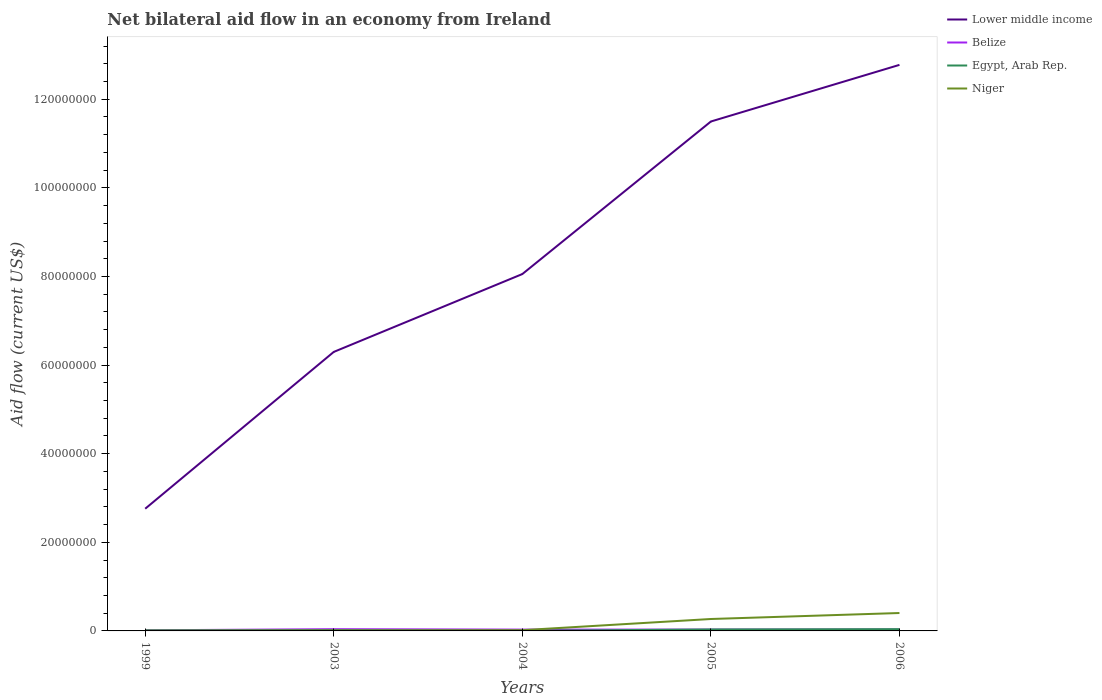How many different coloured lines are there?
Give a very brief answer. 4. Is the number of lines equal to the number of legend labels?
Your response must be concise. Yes. Across all years, what is the maximum net bilateral aid flow in Lower middle income?
Give a very brief answer. 2.76e+07. In which year was the net bilateral aid flow in Lower middle income maximum?
Give a very brief answer. 1999. What is the total net bilateral aid flow in Niger in the graph?
Offer a very short reply. -1.30e+05. What is the difference between the highest and the second highest net bilateral aid flow in Lower middle income?
Your response must be concise. 1.00e+08. What is the difference between the highest and the lowest net bilateral aid flow in Egypt, Arab Rep.?
Your answer should be very brief. 2. Is the net bilateral aid flow in Niger strictly greater than the net bilateral aid flow in Lower middle income over the years?
Provide a succinct answer. Yes. How many years are there in the graph?
Give a very brief answer. 5. Are the values on the major ticks of Y-axis written in scientific E-notation?
Ensure brevity in your answer.  No. Does the graph contain grids?
Offer a terse response. No. Where does the legend appear in the graph?
Ensure brevity in your answer.  Top right. How many legend labels are there?
Ensure brevity in your answer.  4. How are the legend labels stacked?
Provide a succinct answer. Vertical. What is the title of the graph?
Your response must be concise. Net bilateral aid flow in an economy from Ireland. Does "Senegal" appear as one of the legend labels in the graph?
Your response must be concise. No. What is the label or title of the X-axis?
Ensure brevity in your answer.  Years. What is the label or title of the Y-axis?
Your answer should be very brief. Aid flow (current US$). What is the Aid flow (current US$) of Lower middle income in 1999?
Provide a short and direct response. 2.76e+07. What is the Aid flow (current US$) of Belize in 1999?
Offer a terse response. 1.40e+05. What is the Aid flow (current US$) in Egypt, Arab Rep. in 1999?
Your response must be concise. 1.20e+05. What is the Aid flow (current US$) of Niger in 1999?
Ensure brevity in your answer.  4.00e+04. What is the Aid flow (current US$) of Lower middle income in 2003?
Ensure brevity in your answer.  6.30e+07. What is the Aid flow (current US$) of Belize in 2003?
Your answer should be very brief. 3.90e+05. What is the Aid flow (current US$) in Egypt, Arab Rep. in 2003?
Keep it short and to the point. 1.50e+05. What is the Aid flow (current US$) in Niger in 2003?
Offer a very short reply. 1.10e+05. What is the Aid flow (current US$) of Lower middle income in 2004?
Your answer should be compact. 8.05e+07. What is the Aid flow (current US$) in Egypt, Arab Rep. in 2004?
Ensure brevity in your answer.  2.00e+04. What is the Aid flow (current US$) in Niger in 2004?
Give a very brief answer. 1.70e+05. What is the Aid flow (current US$) in Lower middle income in 2005?
Make the answer very short. 1.15e+08. What is the Aid flow (current US$) in Egypt, Arab Rep. in 2005?
Your answer should be very brief. 3.30e+05. What is the Aid flow (current US$) in Niger in 2005?
Give a very brief answer. 2.69e+06. What is the Aid flow (current US$) in Lower middle income in 2006?
Offer a very short reply. 1.28e+08. What is the Aid flow (current US$) in Belize in 2006?
Offer a terse response. 3.10e+05. What is the Aid flow (current US$) of Egypt, Arab Rep. in 2006?
Your response must be concise. 4.00e+05. What is the Aid flow (current US$) in Niger in 2006?
Keep it short and to the point. 4.04e+06. Across all years, what is the maximum Aid flow (current US$) in Lower middle income?
Your response must be concise. 1.28e+08. Across all years, what is the maximum Aid flow (current US$) of Niger?
Your answer should be compact. 4.04e+06. Across all years, what is the minimum Aid flow (current US$) of Lower middle income?
Your answer should be compact. 2.76e+07. Across all years, what is the minimum Aid flow (current US$) in Niger?
Offer a very short reply. 4.00e+04. What is the total Aid flow (current US$) in Lower middle income in the graph?
Keep it short and to the point. 4.14e+08. What is the total Aid flow (current US$) of Belize in the graph?
Offer a very short reply. 1.44e+06. What is the total Aid flow (current US$) in Egypt, Arab Rep. in the graph?
Provide a short and direct response. 1.02e+06. What is the total Aid flow (current US$) in Niger in the graph?
Offer a terse response. 7.05e+06. What is the difference between the Aid flow (current US$) of Lower middle income in 1999 and that in 2003?
Provide a short and direct response. -3.54e+07. What is the difference between the Aid flow (current US$) in Belize in 1999 and that in 2003?
Your response must be concise. -2.50e+05. What is the difference between the Aid flow (current US$) in Egypt, Arab Rep. in 1999 and that in 2003?
Give a very brief answer. -3.00e+04. What is the difference between the Aid flow (current US$) in Lower middle income in 1999 and that in 2004?
Give a very brief answer. -5.30e+07. What is the difference between the Aid flow (current US$) in Belize in 1999 and that in 2004?
Provide a short and direct response. -1.60e+05. What is the difference between the Aid flow (current US$) of Egypt, Arab Rep. in 1999 and that in 2004?
Make the answer very short. 1.00e+05. What is the difference between the Aid flow (current US$) of Niger in 1999 and that in 2004?
Your answer should be compact. -1.30e+05. What is the difference between the Aid flow (current US$) in Lower middle income in 1999 and that in 2005?
Ensure brevity in your answer.  -8.74e+07. What is the difference between the Aid flow (current US$) of Egypt, Arab Rep. in 1999 and that in 2005?
Your response must be concise. -2.10e+05. What is the difference between the Aid flow (current US$) of Niger in 1999 and that in 2005?
Keep it short and to the point. -2.65e+06. What is the difference between the Aid flow (current US$) of Lower middle income in 1999 and that in 2006?
Your answer should be very brief. -1.00e+08. What is the difference between the Aid flow (current US$) of Egypt, Arab Rep. in 1999 and that in 2006?
Make the answer very short. -2.80e+05. What is the difference between the Aid flow (current US$) of Niger in 1999 and that in 2006?
Keep it short and to the point. -4.00e+06. What is the difference between the Aid flow (current US$) in Lower middle income in 2003 and that in 2004?
Give a very brief answer. -1.76e+07. What is the difference between the Aid flow (current US$) in Lower middle income in 2003 and that in 2005?
Ensure brevity in your answer.  -5.20e+07. What is the difference between the Aid flow (current US$) in Egypt, Arab Rep. in 2003 and that in 2005?
Ensure brevity in your answer.  -1.80e+05. What is the difference between the Aid flow (current US$) in Niger in 2003 and that in 2005?
Provide a succinct answer. -2.58e+06. What is the difference between the Aid flow (current US$) of Lower middle income in 2003 and that in 2006?
Keep it short and to the point. -6.48e+07. What is the difference between the Aid flow (current US$) in Niger in 2003 and that in 2006?
Make the answer very short. -3.93e+06. What is the difference between the Aid flow (current US$) in Lower middle income in 2004 and that in 2005?
Provide a short and direct response. -3.44e+07. What is the difference between the Aid flow (current US$) in Belize in 2004 and that in 2005?
Your answer should be very brief. 0. What is the difference between the Aid flow (current US$) of Egypt, Arab Rep. in 2004 and that in 2005?
Offer a very short reply. -3.10e+05. What is the difference between the Aid flow (current US$) in Niger in 2004 and that in 2005?
Provide a short and direct response. -2.52e+06. What is the difference between the Aid flow (current US$) of Lower middle income in 2004 and that in 2006?
Your response must be concise. -4.72e+07. What is the difference between the Aid flow (current US$) in Egypt, Arab Rep. in 2004 and that in 2006?
Keep it short and to the point. -3.80e+05. What is the difference between the Aid flow (current US$) in Niger in 2004 and that in 2006?
Ensure brevity in your answer.  -3.87e+06. What is the difference between the Aid flow (current US$) in Lower middle income in 2005 and that in 2006?
Make the answer very short. -1.28e+07. What is the difference between the Aid flow (current US$) in Niger in 2005 and that in 2006?
Give a very brief answer. -1.35e+06. What is the difference between the Aid flow (current US$) of Lower middle income in 1999 and the Aid flow (current US$) of Belize in 2003?
Give a very brief answer. 2.72e+07. What is the difference between the Aid flow (current US$) in Lower middle income in 1999 and the Aid flow (current US$) in Egypt, Arab Rep. in 2003?
Provide a succinct answer. 2.74e+07. What is the difference between the Aid flow (current US$) in Lower middle income in 1999 and the Aid flow (current US$) in Niger in 2003?
Offer a very short reply. 2.75e+07. What is the difference between the Aid flow (current US$) in Belize in 1999 and the Aid flow (current US$) in Niger in 2003?
Provide a succinct answer. 3.00e+04. What is the difference between the Aid flow (current US$) of Egypt, Arab Rep. in 1999 and the Aid flow (current US$) of Niger in 2003?
Your answer should be compact. 10000. What is the difference between the Aid flow (current US$) of Lower middle income in 1999 and the Aid flow (current US$) of Belize in 2004?
Your response must be concise. 2.73e+07. What is the difference between the Aid flow (current US$) of Lower middle income in 1999 and the Aid flow (current US$) of Egypt, Arab Rep. in 2004?
Offer a terse response. 2.76e+07. What is the difference between the Aid flow (current US$) in Lower middle income in 1999 and the Aid flow (current US$) in Niger in 2004?
Provide a succinct answer. 2.74e+07. What is the difference between the Aid flow (current US$) in Belize in 1999 and the Aid flow (current US$) in Egypt, Arab Rep. in 2004?
Keep it short and to the point. 1.20e+05. What is the difference between the Aid flow (current US$) of Egypt, Arab Rep. in 1999 and the Aid flow (current US$) of Niger in 2004?
Provide a succinct answer. -5.00e+04. What is the difference between the Aid flow (current US$) in Lower middle income in 1999 and the Aid flow (current US$) in Belize in 2005?
Make the answer very short. 2.73e+07. What is the difference between the Aid flow (current US$) in Lower middle income in 1999 and the Aid flow (current US$) in Egypt, Arab Rep. in 2005?
Give a very brief answer. 2.72e+07. What is the difference between the Aid flow (current US$) of Lower middle income in 1999 and the Aid flow (current US$) of Niger in 2005?
Provide a short and direct response. 2.49e+07. What is the difference between the Aid flow (current US$) of Belize in 1999 and the Aid flow (current US$) of Egypt, Arab Rep. in 2005?
Provide a short and direct response. -1.90e+05. What is the difference between the Aid flow (current US$) of Belize in 1999 and the Aid flow (current US$) of Niger in 2005?
Make the answer very short. -2.55e+06. What is the difference between the Aid flow (current US$) of Egypt, Arab Rep. in 1999 and the Aid flow (current US$) of Niger in 2005?
Your response must be concise. -2.57e+06. What is the difference between the Aid flow (current US$) in Lower middle income in 1999 and the Aid flow (current US$) in Belize in 2006?
Offer a terse response. 2.73e+07. What is the difference between the Aid flow (current US$) of Lower middle income in 1999 and the Aid flow (current US$) of Egypt, Arab Rep. in 2006?
Your response must be concise. 2.72e+07. What is the difference between the Aid flow (current US$) in Lower middle income in 1999 and the Aid flow (current US$) in Niger in 2006?
Your answer should be compact. 2.35e+07. What is the difference between the Aid flow (current US$) of Belize in 1999 and the Aid flow (current US$) of Niger in 2006?
Give a very brief answer. -3.90e+06. What is the difference between the Aid flow (current US$) of Egypt, Arab Rep. in 1999 and the Aid flow (current US$) of Niger in 2006?
Give a very brief answer. -3.92e+06. What is the difference between the Aid flow (current US$) in Lower middle income in 2003 and the Aid flow (current US$) in Belize in 2004?
Provide a short and direct response. 6.27e+07. What is the difference between the Aid flow (current US$) in Lower middle income in 2003 and the Aid flow (current US$) in Egypt, Arab Rep. in 2004?
Provide a succinct answer. 6.30e+07. What is the difference between the Aid flow (current US$) of Lower middle income in 2003 and the Aid flow (current US$) of Niger in 2004?
Provide a succinct answer. 6.28e+07. What is the difference between the Aid flow (current US$) of Belize in 2003 and the Aid flow (current US$) of Egypt, Arab Rep. in 2004?
Your answer should be compact. 3.70e+05. What is the difference between the Aid flow (current US$) of Lower middle income in 2003 and the Aid flow (current US$) of Belize in 2005?
Make the answer very short. 6.27e+07. What is the difference between the Aid flow (current US$) of Lower middle income in 2003 and the Aid flow (current US$) of Egypt, Arab Rep. in 2005?
Offer a very short reply. 6.26e+07. What is the difference between the Aid flow (current US$) in Lower middle income in 2003 and the Aid flow (current US$) in Niger in 2005?
Provide a succinct answer. 6.03e+07. What is the difference between the Aid flow (current US$) of Belize in 2003 and the Aid flow (current US$) of Egypt, Arab Rep. in 2005?
Your answer should be compact. 6.00e+04. What is the difference between the Aid flow (current US$) in Belize in 2003 and the Aid flow (current US$) in Niger in 2005?
Offer a very short reply. -2.30e+06. What is the difference between the Aid flow (current US$) in Egypt, Arab Rep. in 2003 and the Aid flow (current US$) in Niger in 2005?
Give a very brief answer. -2.54e+06. What is the difference between the Aid flow (current US$) in Lower middle income in 2003 and the Aid flow (current US$) in Belize in 2006?
Offer a very short reply. 6.27e+07. What is the difference between the Aid flow (current US$) of Lower middle income in 2003 and the Aid flow (current US$) of Egypt, Arab Rep. in 2006?
Provide a short and direct response. 6.26e+07. What is the difference between the Aid flow (current US$) of Lower middle income in 2003 and the Aid flow (current US$) of Niger in 2006?
Your answer should be compact. 5.89e+07. What is the difference between the Aid flow (current US$) of Belize in 2003 and the Aid flow (current US$) of Niger in 2006?
Provide a short and direct response. -3.65e+06. What is the difference between the Aid flow (current US$) in Egypt, Arab Rep. in 2003 and the Aid flow (current US$) in Niger in 2006?
Your response must be concise. -3.89e+06. What is the difference between the Aid flow (current US$) of Lower middle income in 2004 and the Aid flow (current US$) of Belize in 2005?
Make the answer very short. 8.02e+07. What is the difference between the Aid flow (current US$) of Lower middle income in 2004 and the Aid flow (current US$) of Egypt, Arab Rep. in 2005?
Ensure brevity in your answer.  8.02e+07. What is the difference between the Aid flow (current US$) in Lower middle income in 2004 and the Aid flow (current US$) in Niger in 2005?
Give a very brief answer. 7.78e+07. What is the difference between the Aid flow (current US$) of Belize in 2004 and the Aid flow (current US$) of Egypt, Arab Rep. in 2005?
Your response must be concise. -3.00e+04. What is the difference between the Aid flow (current US$) in Belize in 2004 and the Aid flow (current US$) in Niger in 2005?
Offer a terse response. -2.39e+06. What is the difference between the Aid flow (current US$) in Egypt, Arab Rep. in 2004 and the Aid flow (current US$) in Niger in 2005?
Your answer should be very brief. -2.67e+06. What is the difference between the Aid flow (current US$) of Lower middle income in 2004 and the Aid flow (current US$) of Belize in 2006?
Offer a terse response. 8.02e+07. What is the difference between the Aid flow (current US$) of Lower middle income in 2004 and the Aid flow (current US$) of Egypt, Arab Rep. in 2006?
Keep it short and to the point. 8.01e+07. What is the difference between the Aid flow (current US$) in Lower middle income in 2004 and the Aid flow (current US$) in Niger in 2006?
Your answer should be compact. 7.65e+07. What is the difference between the Aid flow (current US$) in Belize in 2004 and the Aid flow (current US$) in Egypt, Arab Rep. in 2006?
Provide a succinct answer. -1.00e+05. What is the difference between the Aid flow (current US$) of Belize in 2004 and the Aid flow (current US$) of Niger in 2006?
Your answer should be compact. -3.74e+06. What is the difference between the Aid flow (current US$) in Egypt, Arab Rep. in 2004 and the Aid flow (current US$) in Niger in 2006?
Keep it short and to the point. -4.02e+06. What is the difference between the Aid flow (current US$) of Lower middle income in 2005 and the Aid flow (current US$) of Belize in 2006?
Provide a succinct answer. 1.15e+08. What is the difference between the Aid flow (current US$) of Lower middle income in 2005 and the Aid flow (current US$) of Egypt, Arab Rep. in 2006?
Your answer should be compact. 1.15e+08. What is the difference between the Aid flow (current US$) in Lower middle income in 2005 and the Aid flow (current US$) in Niger in 2006?
Your answer should be very brief. 1.11e+08. What is the difference between the Aid flow (current US$) of Belize in 2005 and the Aid flow (current US$) of Niger in 2006?
Your response must be concise. -3.74e+06. What is the difference between the Aid flow (current US$) of Egypt, Arab Rep. in 2005 and the Aid flow (current US$) of Niger in 2006?
Keep it short and to the point. -3.71e+06. What is the average Aid flow (current US$) of Lower middle income per year?
Keep it short and to the point. 8.28e+07. What is the average Aid flow (current US$) of Belize per year?
Your answer should be very brief. 2.88e+05. What is the average Aid flow (current US$) of Egypt, Arab Rep. per year?
Ensure brevity in your answer.  2.04e+05. What is the average Aid flow (current US$) of Niger per year?
Make the answer very short. 1.41e+06. In the year 1999, what is the difference between the Aid flow (current US$) in Lower middle income and Aid flow (current US$) in Belize?
Your answer should be compact. 2.74e+07. In the year 1999, what is the difference between the Aid flow (current US$) in Lower middle income and Aid flow (current US$) in Egypt, Arab Rep.?
Your answer should be very brief. 2.75e+07. In the year 1999, what is the difference between the Aid flow (current US$) of Lower middle income and Aid flow (current US$) of Niger?
Provide a succinct answer. 2.75e+07. In the year 1999, what is the difference between the Aid flow (current US$) of Belize and Aid flow (current US$) of Niger?
Provide a short and direct response. 1.00e+05. In the year 1999, what is the difference between the Aid flow (current US$) in Egypt, Arab Rep. and Aid flow (current US$) in Niger?
Offer a very short reply. 8.00e+04. In the year 2003, what is the difference between the Aid flow (current US$) in Lower middle income and Aid flow (current US$) in Belize?
Your answer should be very brief. 6.26e+07. In the year 2003, what is the difference between the Aid flow (current US$) in Lower middle income and Aid flow (current US$) in Egypt, Arab Rep.?
Offer a very short reply. 6.28e+07. In the year 2003, what is the difference between the Aid flow (current US$) of Lower middle income and Aid flow (current US$) of Niger?
Make the answer very short. 6.29e+07. In the year 2003, what is the difference between the Aid flow (current US$) in Belize and Aid flow (current US$) in Niger?
Offer a terse response. 2.80e+05. In the year 2004, what is the difference between the Aid flow (current US$) of Lower middle income and Aid flow (current US$) of Belize?
Your answer should be compact. 8.02e+07. In the year 2004, what is the difference between the Aid flow (current US$) in Lower middle income and Aid flow (current US$) in Egypt, Arab Rep.?
Your response must be concise. 8.05e+07. In the year 2004, what is the difference between the Aid flow (current US$) of Lower middle income and Aid flow (current US$) of Niger?
Ensure brevity in your answer.  8.04e+07. In the year 2004, what is the difference between the Aid flow (current US$) in Belize and Aid flow (current US$) in Niger?
Your answer should be very brief. 1.30e+05. In the year 2004, what is the difference between the Aid flow (current US$) in Egypt, Arab Rep. and Aid flow (current US$) in Niger?
Your answer should be very brief. -1.50e+05. In the year 2005, what is the difference between the Aid flow (current US$) in Lower middle income and Aid flow (current US$) in Belize?
Make the answer very short. 1.15e+08. In the year 2005, what is the difference between the Aid flow (current US$) of Lower middle income and Aid flow (current US$) of Egypt, Arab Rep.?
Ensure brevity in your answer.  1.15e+08. In the year 2005, what is the difference between the Aid flow (current US$) of Lower middle income and Aid flow (current US$) of Niger?
Your answer should be compact. 1.12e+08. In the year 2005, what is the difference between the Aid flow (current US$) of Belize and Aid flow (current US$) of Egypt, Arab Rep.?
Provide a succinct answer. -3.00e+04. In the year 2005, what is the difference between the Aid flow (current US$) of Belize and Aid flow (current US$) of Niger?
Offer a very short reply. -2.39e+06. In the year 2005, what is the difference between the Aid flow (current US$) of Egypt, Arab Rep. and Aid flow (current US$) of Niger?
Give a very brief answer. -2.36e+06. In the year 2006, what is the difference between the Aid flow (current US$) in Lower middle income and Aid flow (current US$) in Belize?
Ensure brevity in your answer.  1.27e+08. In the year 2006, what is the difference between the Aid flow (current US$) in Lower middle income and Aid flow (current US$) in Egypt, Arab Rep.?
Provide a succinct answer. 1.27e+08. In the year 2006, what is the difference between the Aid flow (current US$) in Lower middle income and Aid flow (current US$) in Niger?
Give a very brief answer. 1.24e+08. In the year 2006, what is the difference between the Aid flow (current US$) of Belize and Aid flow (current US$) of Niger?
Your answer should be compact. -3.73e+06. In the year 2006, what is the difference between the Aid flow (current US$) in Egypt, Arab Rep. and Aid flow (current US$) in Niger?
Provide a short and direct response. -3.64e+06. What is the ratio of the Aid flow (current US$) in Lower middle income in 1999 to that in 2003?
Give a very brief answer. 0.44. What is the ratio of the Aid flow (current US$) of Belize in 1999 to that in 2003?
Provide a succinct answer. 0.36. What is the ratio of the Aid flow (current US$) of Egypt, Arab Rep. in 1999 to that in 2003?
Ensure brevity in your answer.  0.8. What is the ratio of the Aid flow (current US$) of Niger in 1999 to that in 2003?
Keep it short and to the point. 0.36. What is the ratio of the Aid flow (current US$) in Lower middle income in 1999 to that in 2004?
Keep it short and to the point. 0.34. What is the ratio of the Aid flow (current US$) of Belize in 1999 to that in 2004?
Give a very brief answer. 0.47. What is the ratio of the Aid flow (current US$) in Egypt, Arab Rep. in 1999 to that in 2004?
Offer a very short reply. 6. What is the ratio of the Aid flow (current US$) of Niger in 1999 to that in 2004?
Keep it short and to the point. 0.24. What is the ratio of the Aid flow (current US$) in Lower middle income in 1999 to that in 2005?
Give a very brief answer. 0.24. What is the ratio of the Aid flow (current US$) of Belize in 1999 to that in 2005?
Keep it short and to the point. 0.47. What is the ratio of the Aid flow (current US$) in Egypt, Arab Rep. in 1999 to that in 2005?
Your answer should be very brief. 0.36. What is the ratio of the Aid flow (current US$) of Niger in 1999 to that in 2005?
Keep it short and to the point. 0.01. What is the ratio of the Aid flow (current US$) of Lower middle income in 1999 to that in 2006?
Your response must be concise. 0.22. What is the ratio of the Aid flow (current US$) of Belize in 1999 to that in 2006?
Give a very brief answer. 0.45. What is the ratio of the Aid flow (current US$) in Egypt, Arab Rep. in 1999 to that in 2006?
Your response must be concise. 0.3. What is the ratio of the Aid flow (current US$) of Niger in 1999 to that in 2006?
Offer a very short reply. 0.01. What is the ratio of the Aid flow (current US$) of Lower middle income in 2003 to that in 2004?
Offer a terse response. 0.78. What is the ratio of the Aid flow (current US$) in Niger in 2003 to that in 2004?
Keep it short and to the point. 0.65. What is the ratio of the Aid flow (current US$) in Lower middle income in 2003 to that in 2005?
Ensure brevity in your answer.  0.55. What is the ratio of the Aid flow (current US$) in Egypt, Arab Rep. in 2003 to that in 2005?
Your answer should be compact. 0.45. What is the ratio of the Aid flow (current US$) in Niger in 2003 to that in 2005?
Your answer should be compact. 0.04. What is the ratio of the Aid flow (current US$) in Lower middle income in 2003 to that in 2006?
Give a very brief answer. 0.49. What is the ratio of the Aid flow (current US$) in Belize in 2003 to that in 2006?
Provide a short and direct response. 1.26. What is the ratio of the Aid flow (current US$) in Egypt, Arab Rep. in 2003 to that in 2006?
Keep it short and to the point. 0.38. What is the ratio of the Aid flow (current US$) in Niger in 2003 to that in 2006?
Offer a very short reply. 0.03. What is the ratio of the Aid flow (current US$) in Lower middle income in 2004 to that in 2005?
Keep it short and to the point. 0.7. What is the ratio of the Aid flow (current US$) of Egypt, Arab Rep. in 2004 to that in 2005?
Provide a succinct answer. 0.06. What is the ratio of the Aid flow (current US$) in Niger in 2004 to that in 2005?
Your answer should be compact. 0.06. What is the ratio of the Aid flow (current US$) of Lower middle income in 2004 to that in 2006?
Offer a very short reply. 0.63. What is the ratio of the Aid flow (current US$) of Belize in 2004 to that in 2006?
Your answer should be compact. 0.97. What is the ratio of the Aid flow (current US$) of Egypt, Arab Rep. in 2004 to that in 2006?
Your answer should be compact. 0.05. What is the ratio of the Aid flow (current US$) of Niger in 2004 to that in 2006?
Your answer should be compact. 0.04. What is the ratio of the Aid flow (current US$) of Egypt, Arab Rep. in 2005 to that in 2006?
Provide a short and direct response. 0.82. What is the ratio of the Aid flow (current US$) in Niger in 2005 to that in 2006?
Provide a short and direct response. 0.67. What is the difference between the highest and the second highest Aid flow (current US$) in Lower middle income?
Offer a terse response. 1.28e+07. What is the difference between the highest and the second highest Aid flow (current US$) in Belize?
Keep it short and to the point. 8.00e+04. What is the difference between the highest and the second highest Aid flow (current US$) of Egypt, Arab Rep.?
Provide a succinct answer. 7.00e+04. What is the difference between the highest and the second highest Aid flow (current US$) of Niger?
Your response must be concise. 1.35e+06. What is the difference between the highest and the lowest Aid flow (current US$) of Lower middle income?
Ensure brevity in your answer.  1.00e+08. 